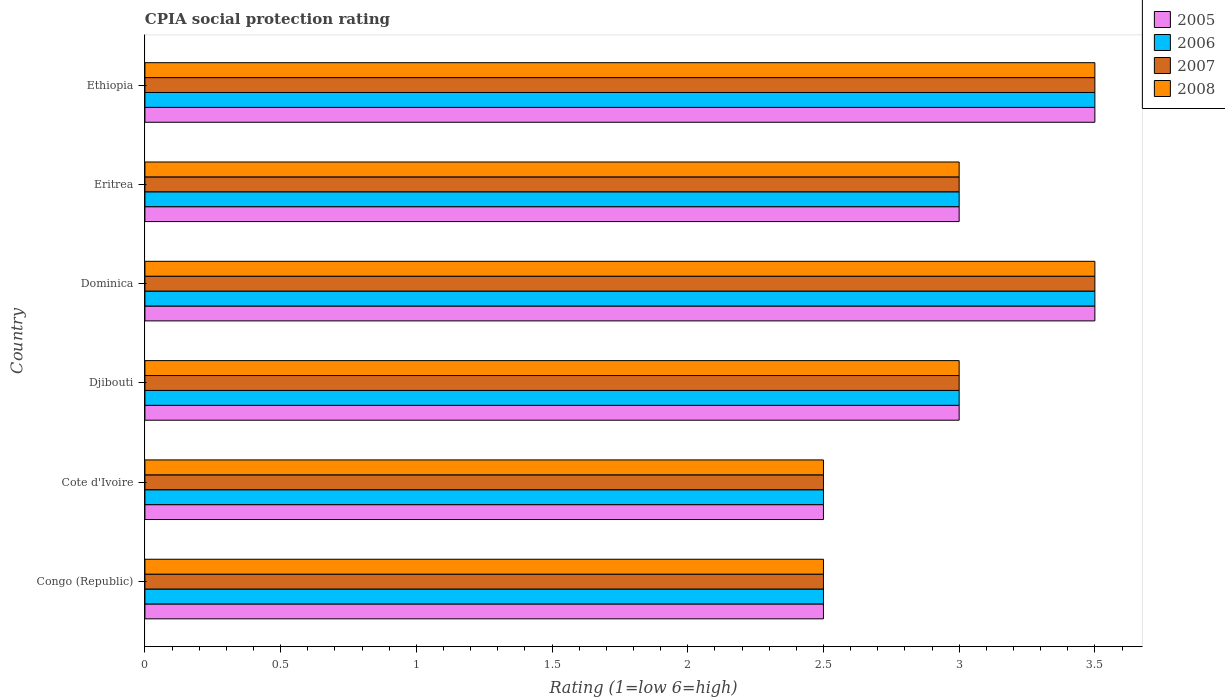How many groups of bars are there?
Keep it short and to the point. 6. Are the number of bars per tick equal to the number of legend labels?
Your response must be concise. Yes. Are the number of bars on each tick of the Y-axis equal?
Ensure brevity in your answer.  Yes. How many bars are there on the 5th tick from the bottom?
Your response must be concise. 4. What is the label of the 5th group of bars from the top?
Offer a very short reply. Cote d'Ivoire. What is the CPIA rating in 2007 in Cote d'Ivoire?
Offer a very short reply. 2.5. In which country was the CPIA rating in 2007 maximum?
Provide a succinct answer. Dominica. In which country was the CPIA rating in 2005 minimum?
Offer a very short reply. Congo (Republic). What is the total CPIA rating in 2008 in the graph?
Your answer should be compact. 18. What is the difference between the CPIA rating in 2005 in Dominica and that in Eritrea?
Your response must be concise. 0.5. What is the average CPIA rating in 2008 per country?
Keep it short and to the point. 3. What is the difference between the CPIA rating in 2005 and CPIA rating in 2008 in Eritrea?
Make the answer very short. 0. In how many countries, is the CPIA rating in 2007 greater than 0.9 ?
Provide a short and direct response. 6. What is the ratio of the CPIA rating in 2007 in Congo (Republic) to that in Cote d'Ivoire?
Your response must be concise. 1. What is the difference between the highest and the second highest CPIA rating in 2008?
Ensure brevity in your answer.  0. In how many countries, is the CPIA rating in 2007 greater than the average CPIA rating in 2007 taken over all countries?
Offer a terse response. 2. Is it the case that in every country, the sum of the CPIA rating in 2005 and CPIA rating in 2006 is greater than the CPIA rating in 2008?
Your answer should be compact. Yes. What is the difference between two consecutive major ticks on the X-axis?
Offer a terse response. 0.5. Are the values on the major ticks of X-axis written in scientific E-notation?
Keep it short and to the point. No. Does the graph contain any zero values?
Your answer should be very brief. No. How many legend labels are there?
Your answer should be very brief. 4. How are the legend labels stacked?
Give a very brief answer. Vertical. What is the title of the graph?
Offer a very short reply. CPIA social protection rating. What is the label or title of the X-axis?
Your response must be concise. Rating (1=low 6=high). What is the Rating (1=low 6=high) in 2005 in Congo (Republic)?
Your answer should be compact. 2.5. What is the Rating (1=low 6=high) in 2006 in Congo (Republic)?
Your answer should be very brief. 2.5. What is the Rating (1=low 6=high) of 2007 in Congo (Republic)?
Keep it short and to the point. 2.5. What is the Rating (1=low 6=high) of 2008 in Congo (Republic)?
Your response must be concise. 2.5. What is the Rating (1=low 6=high) in 2006 in Cote d'Ivoire?
Provide a short and direct response. 2.5. What is the Rating (1=low 6=high) of 2007 in Cote d'Ivoire?
Provide a succinct answer. 2.5. What is the Rating (1=low 6=high) in 2008 in Cote d'Ivoire?
Make the answer very short. 2.5. What is the Rating (1=low 6=high) in 2006 in Djibouti?
Give a very brief answer. 3. What is the Rating (1=low 6=high) of 2008 in Djibouti?
Give a very brief answer. 3. What is the Rating (1=low 6=high) of 2005 in Dominica?
Keep it short and to the point. 3.5. What is the Rating (1=low 6=high) in 2007 in Dominica?
Give a very brief answer. 3.5. What is the Rating (1=low 6=high) of 2008 in Dominica?
Your answer should be very brief. 3.5. What is the Rating (1=low 6=high) in 2007 in Eritrea?
Offer a terse response. 3. What is the Rating (1=low 6=high) in 2008 in Eritrea?
Your response must be concise. 3. What is the Rating (1=low 6=high) in 2005 in Ethiopia?
Keep it short and to the point. 3.5. What is the Rating (1=low 6=high) in 2007 in Ethiopia?
Keep it short and to the point. 3.5. What is the Rating (1=low 6=high) of 2008 in Ethiopia?
Offer a very short reply. 3.5. Across all countries, what is the maximum Rating (1=low 6=high) in 2005?
Provide a short and direct response. 3.5. Across all countries, what is the maximum Rating (1=low 6=high) in 2007?
Give a very brief answer. 3.5. Across all countries, what is the minimum Rating (1=low 6=high) of 2007?
Ensure brevity in your answer.  2.5. What is the difference between the Rating (1=low 6=high) of 2005 in Congo (Republic) and that in Cote d'Ivoire?
Keep it short and to the point. 0. What is the difference between the Rating (1=low 6=high) in 2006 in Congo (Republic) and that in Cote d'Ivoire?
Provide a succinct answer. 0. What is the difference between the Rating (1=low 6=high) of 2007 in Congo (Republic) and that in Cote d'Ivoire?
Ensure brevity in your answer.  0. What is the difference between the Rating (1=low 6=high) in 2005 in Congo (Republic) and that in Dominica?
Your answer should be very brief. -1. What is the difference between the Rating (1=low 6=high) in 2008 in Congo (Republic) and that in Dominica?
Your response must be concise. -1. What is the difference between the Rating (1=low 6=high) in 2005 in Congo (Republic) and that in Eritrea?
Give a very brief answer. -0.5. What is the difference between the Rating (1=low 6=high) in 2007 in Congo (Republic) and that in Eritrea?
Your answer should be very brief. -0.5. What is the difference between the Rating (1=low 6=high) in 2005 in Congo (Republic) and that in Ethiopia?
Provide a succinct answer. -1. What is the difference between the Rating (1=low 6=high) of 2006 in Congo (Republic) and that in Ethiopia?
Give a very brief answer. -1. What is the difference between the Rating (1=low 6=high) of 2007 in Congo (Republic) and that in Ethiopia?
Ensure brevity in your answer.  -1. What is the difference between the Rating (1=low 6=high) of 2006 in Cote d'Ivoire and that in Djibouti?
Your answer should be compact. -0.5. What is the difference between the Rating (1=low 6=high) of 2005 in Cote d'Ivoire and that in Dominica?
Offer a very short reply. -1. What is the difference between the Rating (1=low 6=high) of 2008 in Cote d'Ivoire and that in Dominica?
Your answer should be compact. -1. What is the difference between the Rating (1=low 6=high) of 2007 in Cote d'Ivoire and that in Eritrea?
Provide a succinct answer. -0.5. What is the difference between the Rating (1=low 6=high) of 2007 in Cote d'Ivoire and that in Ethiopia?
Provide a succinct answer. -1. What is the difference between the Rating (1=low 6=high) in 2008 in Cote d'Ivoire and that in Ethiopia?
Make the answer very short. -1. What is the difference between the Rating (1=low 6=high) in 2006 in Djibouti and that in Dominica?
Offer a very short reply. -0.5. What is the difference between the Rating (1=low 6=high) in 2007 in Djibouti and that in Dominica?
Ensure brevity in your answer.  -0.5. What is the difference between the Rating (1=low 6=high) of 2008 in Djibouti and that in Dominica?
Make the answer very short. -0.5. What is the difference between the Rating (1=low 6=high) of 2005 in Djibouti and that in Ethiopia?
Keep it short and to the point. -0.5. What is the difference between the Rating (1=low 6=high) of 2006 in Djibouti and that in Ethiopia?
Keep it short and to the point. -0.5. What is the difference between the Rating (1=low 6=high) of 2007 in Djibouti and that in Ethiopia?
Provide a short and direct response. -0.5. What is the difference between the Rating (1=low 6=high) in 2007 in Dominica and that in Eritrea?
Your response must be concise. 0.5. What is the difference between the Rating (1=low 6=high) of 2008 in Dominica and that in Eritrea?
Your response must be concise. 0.5. What is the difference between the Rating (1=low 6=high) in 2006 in Dominica and that in Ethiopia?
Provide a succinct answer. 0. What is the difference between the Rating (1=low 6=high) of 2008 in Eritrea and that in Ethiopia?
Provide a succinct answer. -0.5. What is the difference between the Rating (1=low 6=high) in 2005 in Congo (Republic) and the Rating (1=low 6=high) in 2006 in Cote d'Ivoire?
Offer a terse response. 0. What is the difference between the Rating (1=low 6=high) of 2007 in Congo (Republic) and the Rating (1=low 6=high) of 2008 in Cote d'Ivoire?
Make the answer very short. 0. What is the difference between the Rating (1=low 6=high) in 2005 in Congo (Republic) and the Rating (1=low 6=high) in 2007 in Djibouti?
Your answer should be very brief. -0.5. What is the difference between the Rating (1=low 6=high) in 2005 in Congo (Republic) and the Rating (1=low 6=high) in 2008 in Djibouti?
Keep it short and to the point. -0.5. What is the difference between the Rating (1=low 6=high) in 2006 in Congo (Republic) and the Rating (1=low 6=high) in 2007 in Djibouti?
Offer a very short reply. -0.5. What is the difference between the Rating (1=low 6=high) of 2006 in Congo (Republic) and the Rating (1=low 6=high) of 2008 in Djibouti?
Your answer should be compact. -0.5. What is the difference between the Rating (1=low 6=high) in 2005 in Congo (Republic) and the Rating (1=low 6=high) in 2006 in Dominica?
Make the answer very short. -1. What is the difference between the Rating (1=low 6=high) of 2005 in Congo (Republic) and the Rating (1=low 6=high) of 2007 in Dominica?
Offer a very short reply. -1. What is the difference between the Rating (1=low 6=high) of 2005 in Congo (Republic) and the Rating (1=low 6=high) of 2008 in Dominica?
Keep it short and to the point. -1. What is the difference between the Rating (1=low 6=high) of 2007 in Congo (Republic) and the Rating (1=low 6=high) of 2008 in Dominica?
Your answer should be compact. -1. What is the difference between the Rating (1=low 6=high) in 2005 in Congo (Republic) and the Rating (1=low 6=high) in 2007 in Eritrea?
Ensure brevity in your answer.  -0.5. What is the difference between the Rating (1=low 6=high) of 2005 in Congo (Republic) and the Rating (1=low 6=high) of 2008 in Ethiopia?
Your answer should be compact. -1. What is the difference between the Rating (1=low 6=high) in 2005 in Cote d'Ivoire and the Rating (1=low 6=high) in 2006 in Djibouti?
Offer a terse response. -0.5. What is the difference between the Rating (1=low 6=high) of 2005 in Cote d'Ivoire and the Rating (1=low 6=high) of 2007 in Djibouti?
Make the answer very short. -0.5. What is the difference between the Rating (1=low 6=high) of 2005 in Cote d'Ivoire and the Rating (1=low 6=high) of 2008 in Djibouti?
Your answer should be compact. -0.5. What is the difference between the Rating (1=low 6=high) in 2006 in Cote d'Ivoire and the Rating (1=low 6=high) in 2007 in Djibouti?
Provide a succinct answer. -0.5. What is the difference between the Rating (1=low 6=high) of 2007 in Cote d'Ivoire and the Rating (1=low 6=high) of 2008 in Djibouti?
Provide a short and direct response. -0.5. What is the difference between the Rating (1=low 6=high) of 2005 in Cote d'Ivoire and the Rating (1=low 6=high) of 2007 in Dominica?
Offer a terse response. -1. What is the difference between the Rating (1=low 6=high) in 2005 in Cote d'Ivoire and the Rating (1=low 6=high) in 2008 in Dominica?
Offer a terse response. -1. What is the difference between the Rating (1=low 6=high) of 2006 in Cote d'Ivoire and the Rating (1=low 6=high) of 2008 in Dominica?
Your answer should be compact. -1. What is the difference between the Rating (1=low 6=high) in 2005 in Cote d'Ivoire and the Rating (1=low 6=high) in 2007 in Eritrea?
Provide a succinct answer. -0.5. What is the difference between the Rating (1=low 6=high) of 2006 in Cote d'Ivoire and the Rating (1=low 6=high) of 2008 in Eritrea?
Provide a short and direct response. -0.5. What is the difference between the Rating (1=low 6=high) in 2007 in Cote d'Ivoire and the Rating (1=low 6=high) in 2008 in Eritrea?
Your answer should be compact. -0.5. What is the difference between the Rating (1=low 6=high) in 2005 in Cote d'Ivoire and the Rating (1=low 6=high) in 2006 in Ethiopia?
Make the answer very short. -1. What is the difference between the Rating (1=low 6=high) in 2005 in Cote d'Ivoire and the Rating (1=low 6=high) in 2008 in Ethiopia?
Your response must be concise. -1. What is the difference between the Rating (1=low 6=high) of 2006 in Cote d'Ivoire and the Rating (1=low 6=high) of 2008 in Ethiopia?
Ensure brevity in your answer.  -1. What is the difference between the Rating (1=low 6=high) of 2006 in Djibouti and the Rating (1=low 6=high) of 2008 in Dominica?
Offer a terse response. -0.5. What is the difference between the Rating (1=low 6=high) in 2005 in Djibouti and the Rating (1=low 6=high) in 2006 in Eritrea?
Your response must be concise. 0. What is the difference between the Rating (1=low 6=high) of 2007 in Djibouti and the Rating (1=low 6=high) of 2008 in Eritrea?
Keep it short and to the point. 0. What is the difference between the Rating (1=low 6=high) of 2005 in Djibouti and the Rating (1=low 6=high) of 2006 in Ethiopia?
Offer a very short reply. -0.5. What is the difference between the Rating (1=low 6=high) of 2005 in Djibouti and the Rating (1=low 6=high) of 2007 in Ethiopia?
Offer a very short reply. -0.5. What is the difference between the Rating (1=low 6=high) in 2005 in Djibouti and the Rating (1=low 6=high) in 2008 in Ethiopia?
Make the answer very short. -0.5. What is the difference between the Rating (1=low 6=high) of 2006 in Djibouti and the Rating (1=low 6=high) of 2007 in Ethiopia?
Make the answer very short. -0.5. What is the difference between the Rating (1=low 6=high) of 2007 in Djibouti and the Rating (1=low 6=high) of 2008 in Ethiopia?
Your answer should be compact. -0.5. What is the difference between the Rating (1=low 6=high) of 2005 in Dominica and the Rating (1=low 6=high) of 2007 in Eritrea?
Provide a succinct answer. 0.5. What is the difference between the Rating (1=low 6=high) in 2005 in Dominica and the Rating (1=low 6=high) in 2008 in Eritrea?
Offer a terse response. 0.5. What is the difference between the Rating (1=low 6=high) in 2006 in Dominica and the Rating (1=low 6=high) in 2007 in Eritrea?
Your response must be concise. 0.5. What is the difference between the Rating (1=low 6=high) in 2006 in Dominica and the Rating (1=low 6=high) in 2008 in Eritrea?
Provide a succinct answer. 0.5. What is the difference between the Rating (1=low 6=high) of 2005 in Dominica and the Rating (1=low 6=high) of 2007 in Ethiopia?
Your answer should be compact. 0. What is the difference between the Rating (1=low 6=high) of 2006 in Dominica and the Rating (1=low 6=high) of 2007 in Ethiopia?
Ensure brevity in your answer.  0. What is the difference between the Rating (1=low 6=high) of 2006 in Dominica and the Rating (1=low 6=high) of 2008 in Ethiopia?
Ensure brevity in your answer.  0. What is the difference between the Rating (1=low 6=high) in 2005 in Eritrea and the Rating (1=low 6=high) in 2007 in Ethiopia?
Your response must be concise. -0.5. What is the difference between the Rating (1=low 6=high) in 2006 in Eritrea and the Rating (1=low 6=high) in 2007 in Ethiopia?
Offer a very short reply. -0.5. What is the difference between the Rating (1=low 6=high) of 2007 in Eritrea and the Rating (1=low 6=high) of 2008 in Ethiopia?
Give a very brief answer. -0.5. What is the average Rating (1=low 6=high) in 2006 per country?
Offer a terse response. 3. What is the average Rating (1=low 6=high) of 2008 per country?
Your answer should be very brief. 3. What is the difference between the Rating (1=low 6=high) of 2005 and Rating (1=low 6=high) of 2006 in Congo (Republic)?
Ensure brevity in your answer.  0. What is the difference between the Rating (1=low 6=high) of 2005 and Rating (1=low 6=high) of 2007 in Congo (Republic)?
Keep it short and to the point. 0. What is the difference between the Rating (1=low 6=high) in 2007 and Rating (1=low 6=high) in 2008 in Congo (Republic)?
Keep it short and to the point. 0. What is the difference between the Rating (1=low 6=high) of 2005 and Rating (1=low 6=high) of 2006 in Cote d'Ivoire?
Keep it short and to the point. 0. What is the difference between the Rating (1=low 6=high) of 2005 and Rating (1=low 6=high) of 2007 in Cote d'Ivoire?
Provide a short and direct response. 0. What is the difference between the Rating (1=low 6=high) in 2006 and Rating (1=low 6=high) in 2008 in Cote d'Ivoire?
Give a very brief answer. 0. What is the difference between the Rating (1=low 6=high) in 2005 and Rating (1=low 6=high) in 2006 in Djibouti?
Provide a short and direct response. 0. What is the difference between the Rating (1=low 6=high) of 2005 and Rating (1=low 6=high) of 2007 in Djibouti?
Your answer should be compact. 0. What is the difference between the Rating (1=low 6=high) of 2006 and Rating (1=low 6=high) of 2007 in Djibouti?
Provide a succinct answer. 0. What is the difference between the Rating (1=low 6=high) in 2006 and Rating (1=low 6=high) in 2008 in Djibouti?
Make the answer very short. 0. What is the difference between the Rating (1=low 6=high) in 2007 and Rating (1=low 6=high) in 2008 in Djibouti?
Provide a succinct answer. 0. What is the difference between the Rating (1=low 6=high) in 2005 and Rating (1=low 6=high) in 2007 in Dominica?
Provide a succinct answer. 0. What is the difference between the Rating (1=low 6=high) of 2005 and Rating (1=low 6=high) of 2008 in Dominica?
Your answer should be compact. 0. What is the difference between the Rating (1=low 6=high) of 2006 and Rating (1=low 6=high) of 2008 in Dominica?
Make the answer very short. 0. What is the difference between the Rating (1=low 6=high) of 2005 and Rating (1=low 6=high) of 2007 in Eritrea?
Provide a succinct answer. 0. What is the difference between the Rating (1=low 6=high) of 2007 and Rating (1=low 6=high) of 2008 in Eritrea?
Provide a short and direct response. 0. What is the difference between the Rating (1=low 6=high) in 2006 and Rating (1=low 6=high) in 2007 in Ethiopia?
Provide a short and direct response. 0. What is the difference between the Rating (1=low 6=high) of 2006 and Rating (1=low 6=high) of 2008 in Ethiopia?
Offer a very short reply. 0. What is the ratio of the Rating (1=low 6=high) of 2005 in Congo (Republic) to that in Cote d'Ivoire?
Keep it short and to the point. 1. What is the ratio of the Rating (1=low 6=high) in 2008 in Congo (Republic) to that in Cote d'Ivoire?
Give a very brief answer. 1. What is the ratio of the Rating (1=low 6=high) in 2006 in Congo (Republic) to that in Djibouti?
Make the answer very short. 0.83. What is the ratio of the Rating (1=low 6=high) of 2005 in Congo (Republic) to that in Dominica?
Keep it short and to the point. 0.71. What is the ratio of the Rating (1=low 6=high) in 2007 in Congo (Republic) to that in Eritrea?
Provide a succinct answer. 0.83. What is the ratio of the Rating (1=low 6=high) of 2005 in Congo (Republic) to that in Ethiopia?
Offer a terse response. 0.71. What is the ratio of the Rating (1=low 6=high) of 2007 in Congo (Republic) to that in Ethiopia?
Your answer should be very brief. 0.71. What is the ratio of the Rating (1=low 6=high) of 2008 in Congo (Republic) to that in Ethiopia?
Offer a terse response. 0.71. What is the ratio of the Rating (1=low 6=high) in 2005 in Cote d'Ivoire to that in Djibouti?
Offer a very short reply. 0.83. What is the ratio of the Rating (1=low 6=high) in 2008 in Cote d'Ivoire to that in Djibouti?
Offer a terse response. 0.83. What is the ratio of the Rating (1=low 6=high) of 2005 in Cote d'Ivoire to that in Dominica?
Your answer should be compact. 0.71. What is the ratio of the Rating (1=low 6=high) in 2006 in Cote d'Ivoire to that in Dominica?
Give a very brief answer. 0.71. What is the ratio of the Rating (1=low 6=high) in 2007 in Cote d'Ivoire to that in Dominica?
Give a very brief answer. 0.71. What is the ratio of the Rating (1=low 6=high) in 2008 in Cote d'Ivoire to that in Dominica?
Make the answer very short. 0.71. What is the ratio of the Rating (1=low 6=high) in 2005 in Cote d'Ivoire to that in Eritrea?
Provide a succinct answer. 0.83. What is the ratio of the Rating (1=low 6=high) of 2005 in Cote d'Ivoire to that in Ethiopia?
Provide a succinct answer. 0.71. What is the ratio of the Rating (1=low 6=high) in 2006 in Cote d'Ivoire to that in Ethiopia?
Ensure brevity in your answer.  0.71. What is the ratio of the Rating (1=low 6=high) in 2005 in Djibouti to that in Dominica?
Keep it short and to the point. 0.86. What is the ratio of the Rating (1=low 6=high) of 2006 in Djibouti to that in Eritrea?
Provide a succinct answer. 1. What is the ratio of the Rating (1=low 6=high) in 2007 in Djibouti to that in Eritrea?
Make the answer very short. 1. What is the ratio of the Rating (1=low 6=high) of 2008 in Djibouti to that in Eritrea?
Your answer should be compact. 1. What is the ratio of the Rating (1=low 6=high) in 2006 in Djibouti to that in Ethiopia?
Ensure brevity in your answer.  0.86. What is the ratio of the Rating (1=low 6=high) in 2007 in Djibouti to that in Ethiopia?
Offer a very short reply. 0.86. What is the ratio of the Rating (1=low 6=high) of 2005 in Dominica to that in Eritrea?
Make the answer very short. 1.17. What is the ratio of the Rating (1=low 6=high) of 2007 in Dominica to that in Eritrea?
Ensure brevity in your answer.  1.17. What is the ratio of the Rating (1=low 6=high) of 2008 in Dominica to that in Eritrea?
Your response must be concise. 1.17. What is the ratio of the Rating (1=low 6=high) in 2006 in Dominica to that in Ethiopia?
Make the answer very short. 1. What is the ratio of the Rating (1=low 6=high) in 2008 in Dominica to that in Ethiopia?
Provide a short and direct response. 1. What is the ratio of the Rating (1=low 6=high) in 2007 in Eritrea to that in Ethiopia?
Your answer should be compact. 0.86. What is the difference between the highest and the second highest Rating (1=low 6=high) of 2005?
Keep it short and to the point. 0. What is the difference between the highest and the second highest Rating (1=low 6=high) of 2006?
Ensure brevity in your answer.  0. What is the difference between the highest and the second highest Rating (1=low 6=high) in 2007?
Keep it short and to the point. 0. What is the difference between the highest and the lowest Rating (1=low 6=high) in 2006?
Your answer should be compact. 1. What is the difference between the highest and the lowest Rating (1=low 6=high) in 2007?
Keep it short and to the point. 1. 